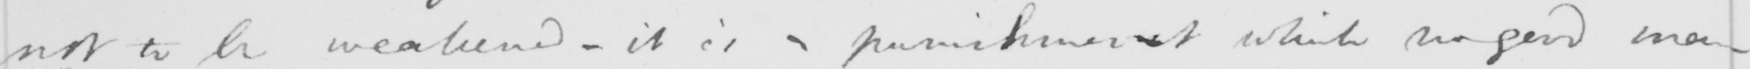What text is written in this handwritten line? not to be weakened  _  it is a punishment no good man 